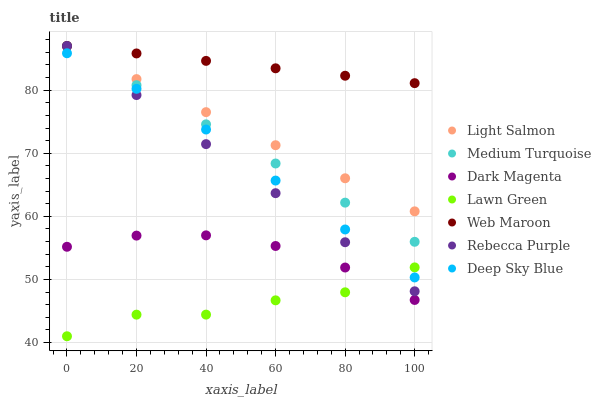Does Lawn Green have the minimum area under the curve?
Answer yes or no. Yes. Does Web Maroon have the maximum area under the curve?
Answer yes or no. Yes. Does Light Salmon have the minimum area under the curve?
Answer yes or no. No. Does Light Salmon have the maximum area under the curve?
Answer yes or no. No. Is Medium Turquoise the smoothest?
Answer yes or no. Yes. Is Lawn Green the roughest?
Answer yes or no. Yes. Is Light Salmon the smoothest?
Answer yes or no. No. Is Light Salmon the roughest?
Answer yes or no. No. Does Lawn Green have the lowest value?
Answer yes or no. Yes. Does Light Salmon have the lowest value?
Answer yes or no. No. Does Medium Turquoise have the highest value?
Answer yes or no. Yes. Does Dark Magenta have the highest value?
Answer yes or no. No. Is Dark Magenta less than Rebecca Purple?
Answer yes or no. Yes. Is Deep Sky Blue greater than Dark Magenta?
Answer yes or no. Yes. Does Lawn Green intersect Deep Sky Blue?
Answer yes or no. Yes. Is Lawn Green less than Deep Sky Blue?
Answer yes or no. No. Is Lawn Green greater than Deep Sky Blue?
Answer yes or no. No. Does Dark Magenta intersect Rebecca Purple?
Answer yes or no. No. 